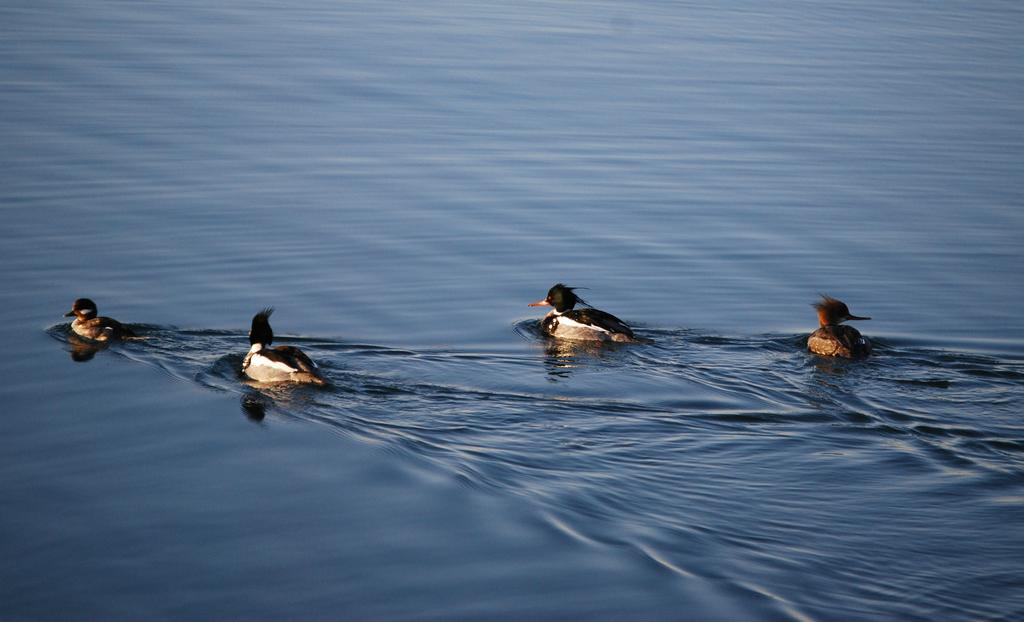What is the primary element visible in the image? There is water in the image. What type of animals can be seen in the water? There are ducks in the water. Where can the snakes be seen swimming in the image? There are no snakes present in the image. What type of brush is used to clean the sea in the image? The image does not depict a sea or any cleaning activity, so there is no brush present. 